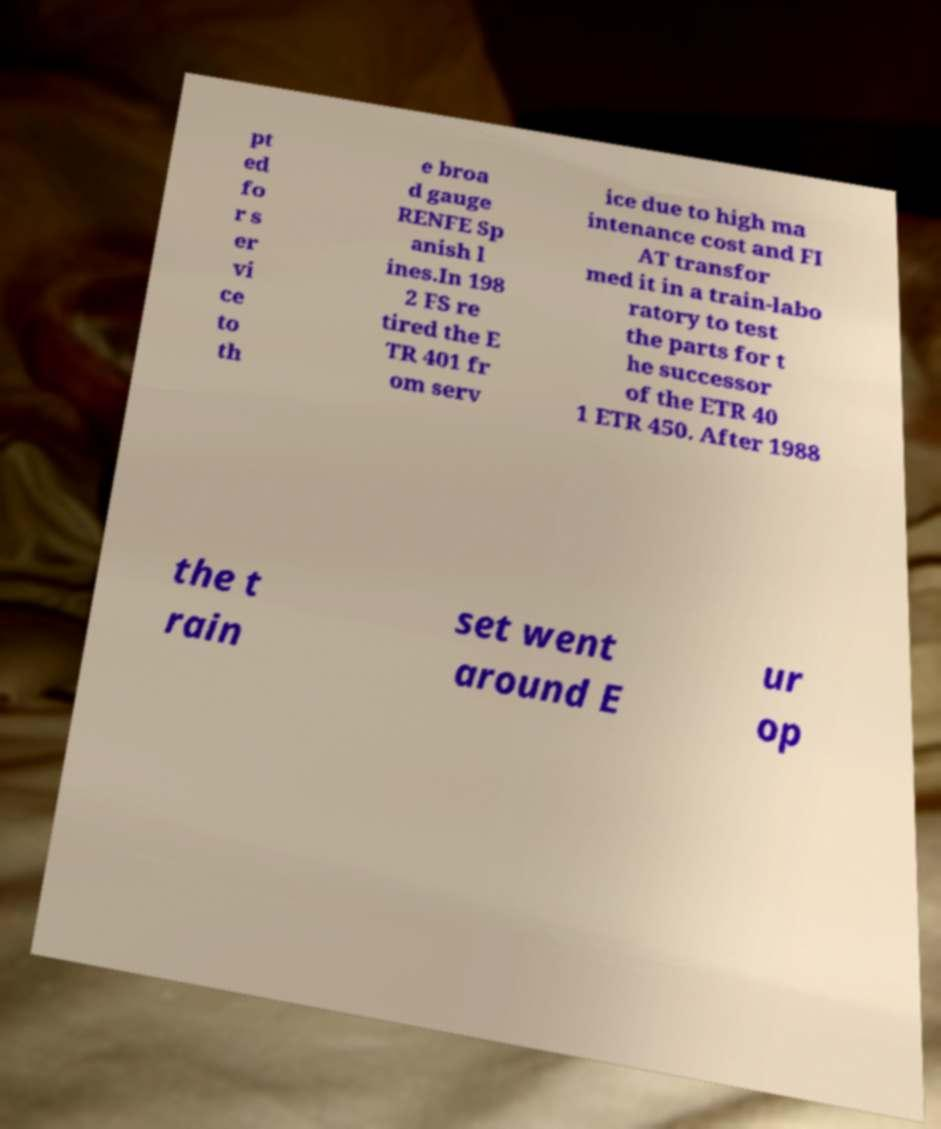Can you accurately transcribe the text from the provided image for me? pt ed fo r s er vi ce to th e broa d gauge RENFE Sp anish l ines.In 198 2 FS re tired the E TR 401 fr om serv ice due to high ma intenance cost and FI AT transfor med it in a train-labo ratory to test the parts for t he successor of the ETR 40 1 ETR 450. After 1988 the t rain set went around E ur op 